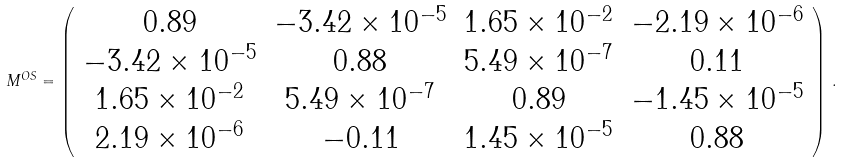Convert formula to latex. <formula><loc_0><loc_0><loc_500><loc_500>M ^ { O S } = \left ( \begin{array} { c c c c } 0 . 8 9 & - 3 . 4 2 \times 1 0 ^ { - 5 } & 1 . 6 5 \times 1 0 ^ { - 2 } & - 2 . 1 9 \times 1 0 ^ { - 6 } \\ - 3 . 4 2 \times 1 0 ^ { - 5 } & 0 . 8 8 & 5 . 4 9 \times 1 0 ^ { - 7 } & 0 . 1 1 \\ 1 . 6 5 \times 1 0 ^ { - 2 } & 5 . 4 9 \times 1 0 ^ { - 7 } & 0 . 8 9 & - 1 . 4 5 \times 1 0 ^ { - 5 } \\ 2 . 1 9 \times 1 0 ^ { - 6 } & - 0 . 1 1 & 1 . 4 5 \times 1 0 ^ { - 5 } & 0 . 8 8 \\ \end{array} \right ) \, .</formula> 